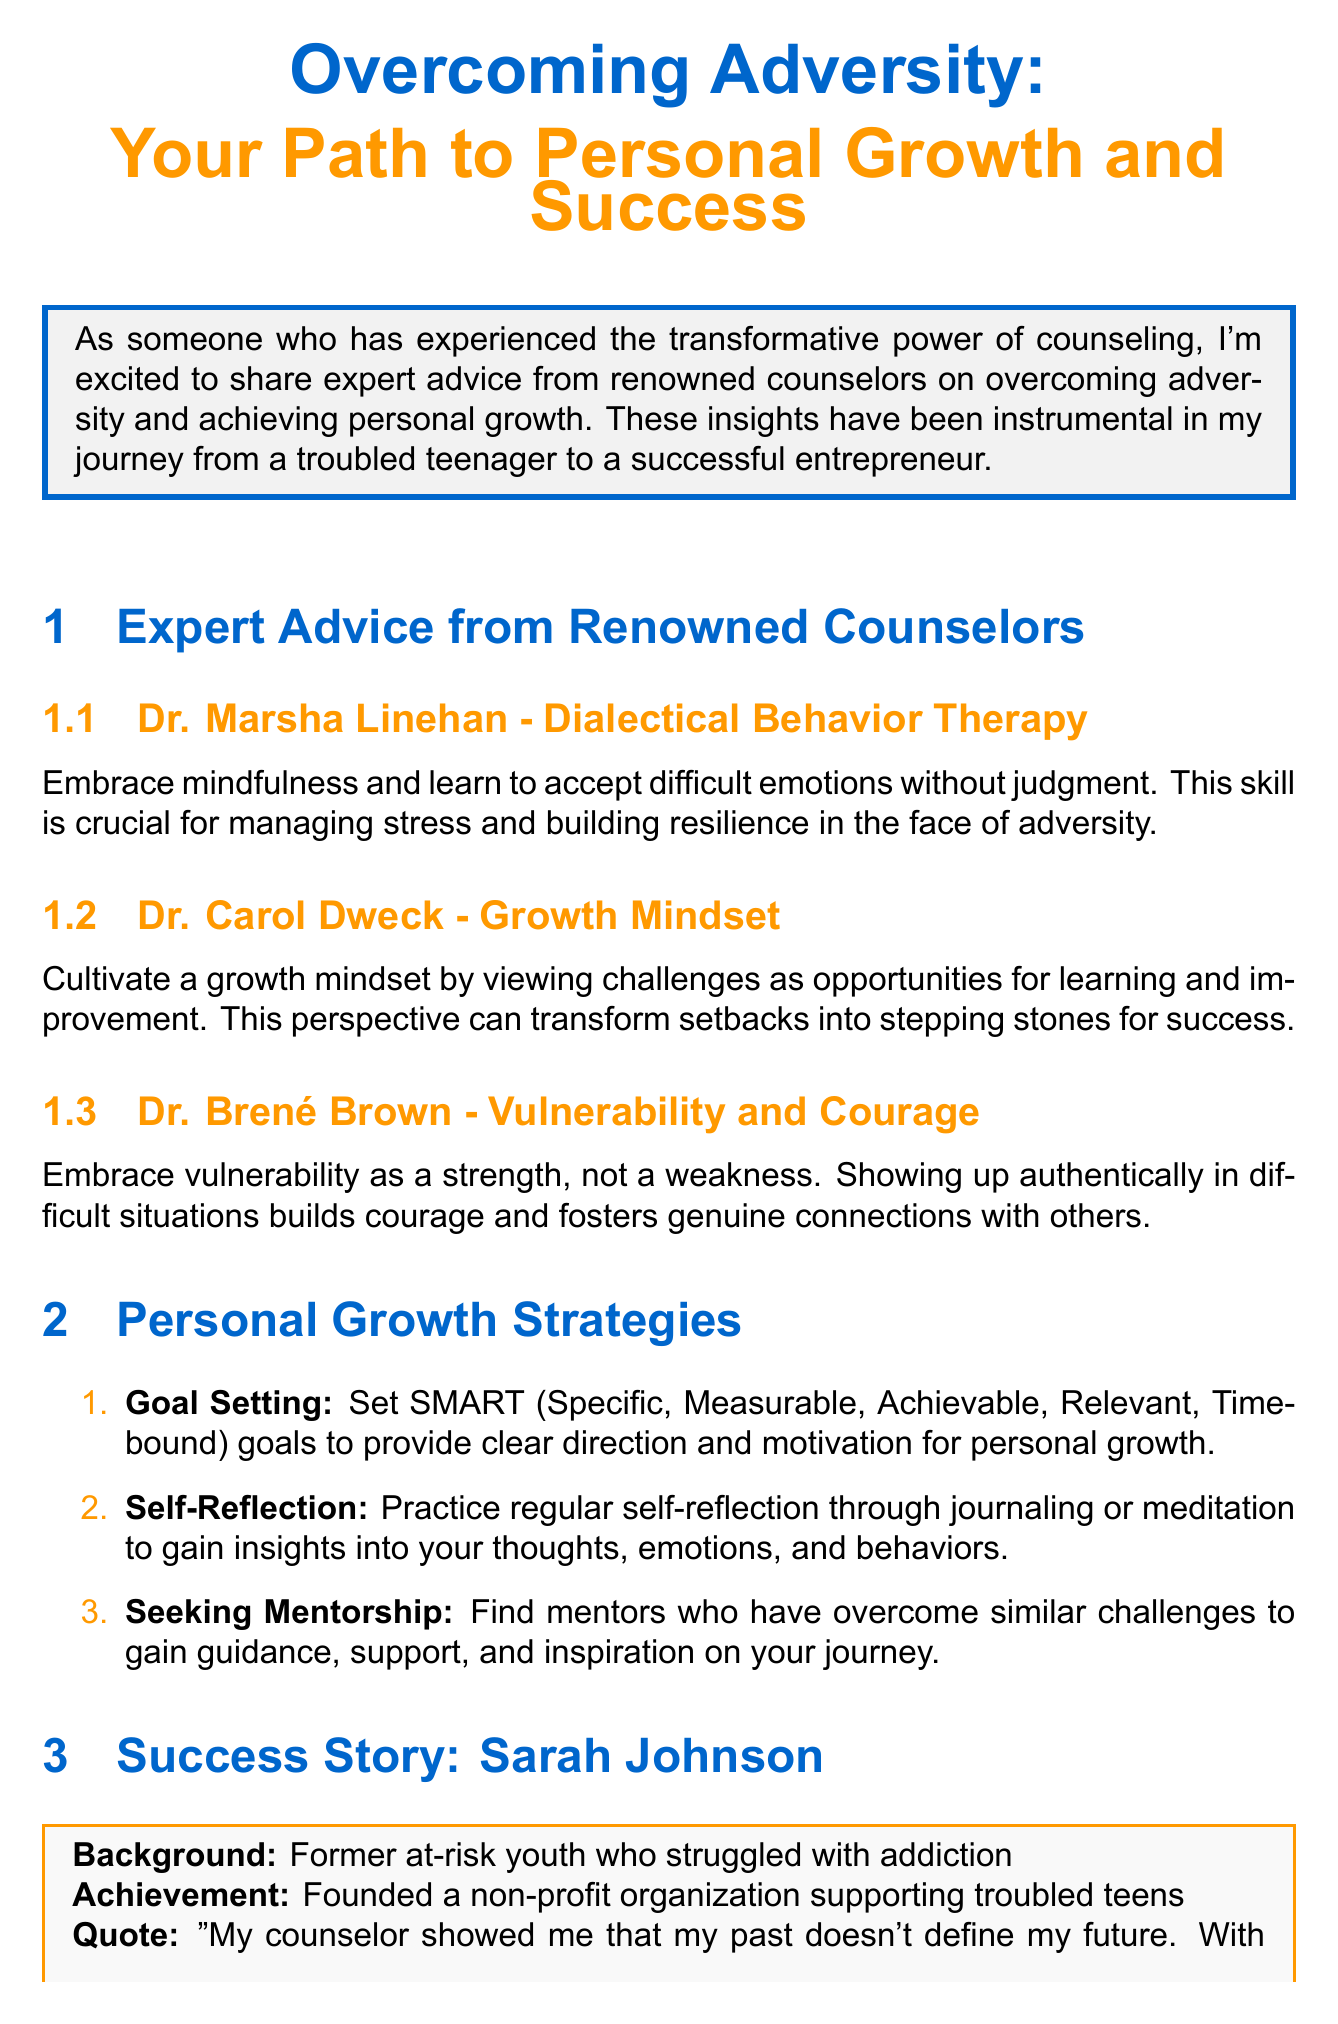What is the title of the newsletter? The title of the newsletter is stated at the beginning of the document.
Answer: Overcoming Adversity: Your Path to Personal Growth and Success Who is the featured counselor that specializes in Dialectical Behavior Therapy? The document lists counselors along with their areas of expertise, including Dialectical Behavior Therapy.
Answer: Dr. Marsha Linehan What personal growth strategy involves journaling or meditation? The document outlines various personal growth strategies and describes one that focuses on introspection.
Answer: Self-Reflection What is the name of the success story featured in the newsletter? The newsletter includes a specific individual as a success story, highlighting her background and achievements.
Answer: Sarah Johnson What book is recommended by Dr. Carol Dweck? The document provides a list of recommended books, including one authored by Dr. Carol Dweck.
Answer: Mindset: The New Psychology of Success How does Sarah Johnson describe her transformation? The success story includes a quote reflecting on personal change and growth, which captures her thoughts on her journey.
Answer: My past doesn't define my future What type of resource is "Therapy in a Nutshell"? The document categorizes various resources, specifying the format of each recommendation.
Answer: Video Series What is encouraged as a sign of strength in the call to action? The call to action conveys an important message about seeking help, which is highlighted in the document.
Answer: Seeking help 